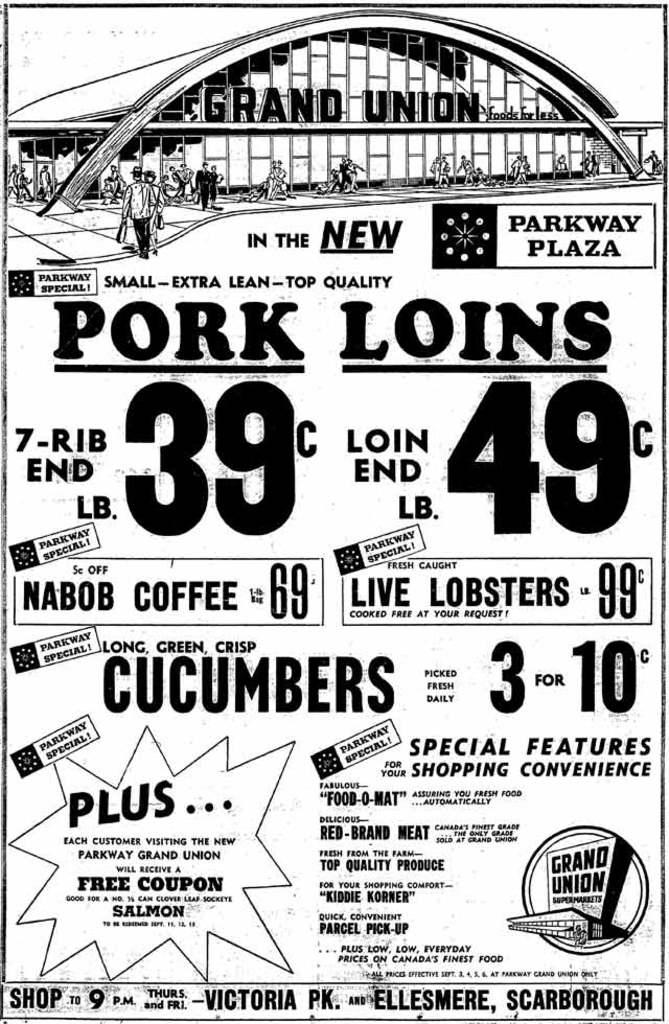What is the color scheme of the poster in the image? The poster is black and white. What type of information is displayed on the poster? There are texts and numbers on the poster. What can be seen in the image besides the poster? There are people standing on the ground in the image. What type of structure is visible in the image? There is a building in the image. What type of dinner is being served in the image? There is no dinner present in the image. --- Facts: 1. There is a person in the image. 2. The person is wearing a hat. 3. The person is holding a book. 4. The person is standing in front of a bookshelf. 5. The bookshelf is filled with books. Absurd Topics: elephant, bicycle, ocean Conversation: What is there is a person in the image? Yes, there is a person in the image. What is the person in the image wearing? The person is wearing a hat. What is the person in the image holding? The person is holding a book. Where is the person in the image standing? The person is standing in front of a bookshelf. What can be seen on the bookshelf in the image? The bookshelf is filled with books. Reasoning: Let's think step by step in order to produce the conversation. We start by identifying the main subject of the image, which is the person. Then, we describe the person's attire, mentioning that they are wearing a hat. Next, we observe what the person is holding, which is a book. After that, we describe the person's location, noting that they are standing in front of a bookshelf. Finally, we describe the bookshelf's content, mentioning that it is filled with books. Absurd Question/Answer: Can you see an elephant riding a bicycle near the ocean in the image? No, there is no elephant, bicycle, or ocean present in the image. 